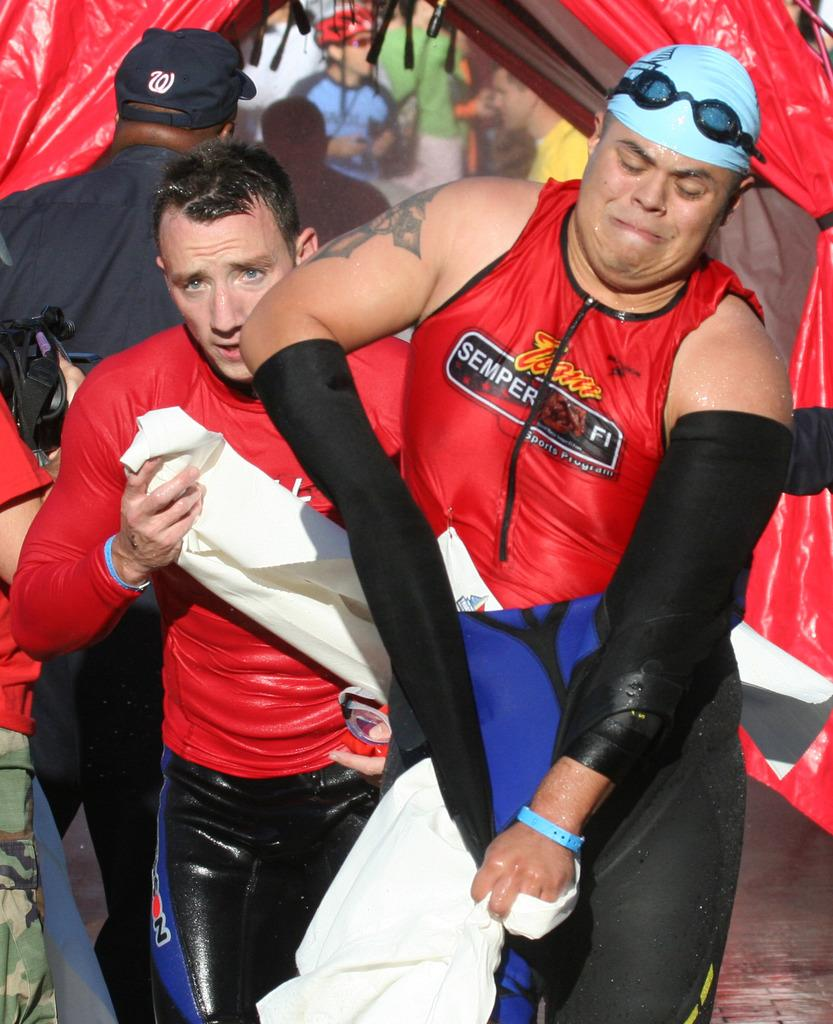<image>
Describe the image concisely. Team Seper Fi wears a red and black top as they towel off. 